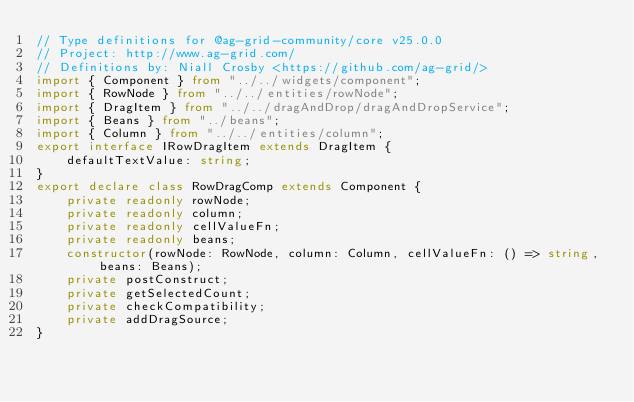<code> <loc_0><loc_0><loc_500><loc_500><_TypeScript_>// Type definitions for @ag-grid-community/core v25.0.0
// Project: http://www.ag-grid.com/
// Definitions by: Niall Crosby <https://github.com/ag-grid/>
import { Component } from "../../widgets/component";
import { RowNode } from "../../entities/rowNode";
import { DragItem } from "../../dragAndDrop/dragAndDropService";
import { Beans } from "../beans";
import { Column } from "../../entities/column";
export interface IRowDragItem extends DragItem {
    defaultTextValue: string;
}
export declare class RowDragComp extends Component {
    private readonly rowNode;
    private readonly column;
    private readonly cellValueFn;
    private readonly beans;
    constructor(rowNode: RowNode, column: Column, cellValueFn: () => string, beans: Beans);
    private postConstruct;
    private getSelectedCount;
    private checkCompatibility;
    private addDragSource;
}
</code> 